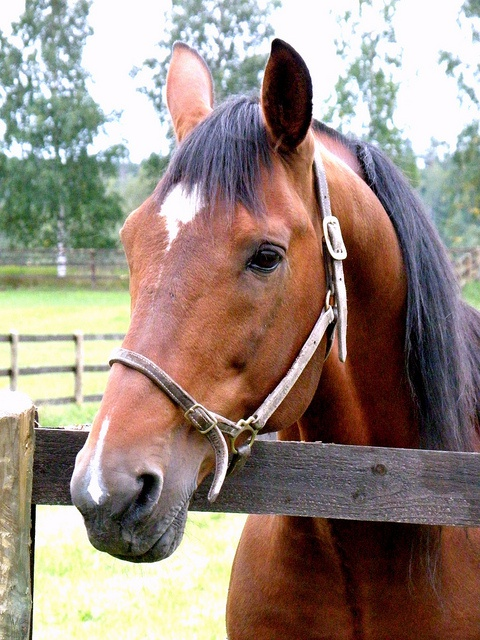Describe the objects in this image and their specific colors. I can see a horse in white, black, gray, maroon, and brown tones in this image. 